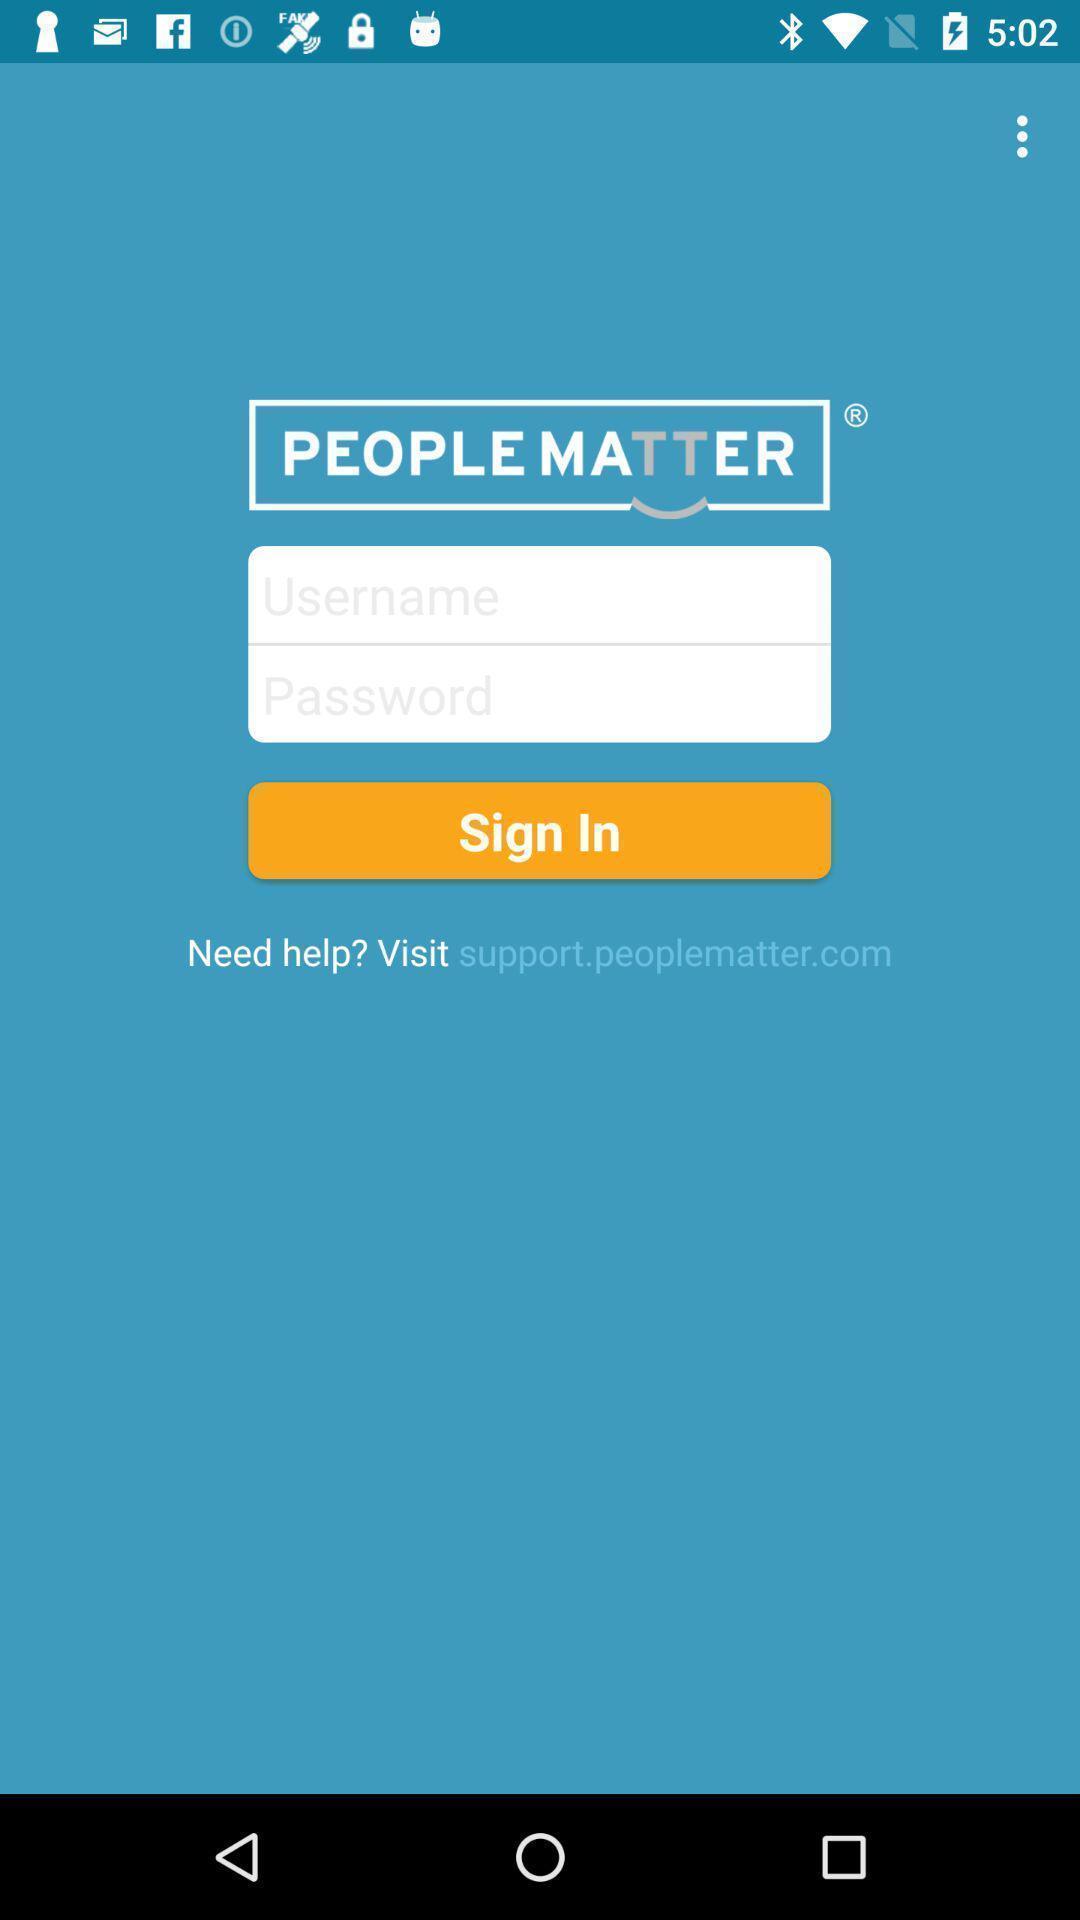Summarize the main components in this picture. Sign up page of a mobile app. 